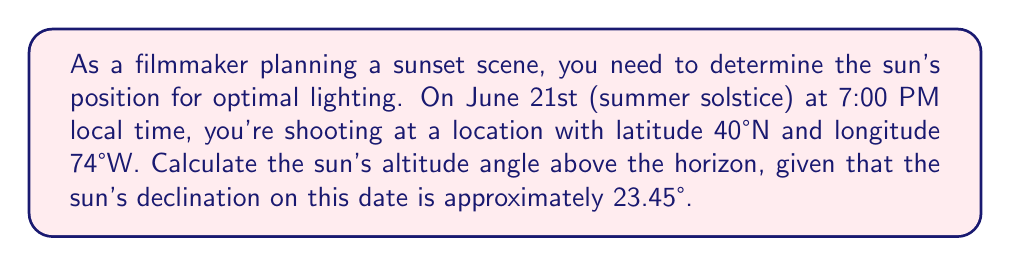Could you help me with this problem? To solve this problem, we'll use the celestial sphere model and the equation for solar altitude:

1. The equation for solar altitude is:
   $$\sin(h) = \sin(\phi)\sin(\delta) + \cos(\phi)\cos(\delta)\cos(H)$$
   Where:
   $h$ = solar altitude
   $\phi$ = latitude
   $\delta$ = solar declination
   $H$ = hour angle

2. We're given:
   $\phi = 40°$ (latitude)
   $\delta = 23.45°$ (declination on summer solstice)

3. Calculate the hour angle (H):
   - Local solar noon occurs when the sun is highest in the sky.
   - 7:00 PM is 7 hours after noon, so H = 15° × 7 = 105°
   
4. Substitute values into the equation:
   $$\sin(h) = \sin(40°)\sin(23.45°) + \cos(40°)\cos(23.45°)\cos(105°)$$

5. Calculate step by step:
   $$\sin(h) = (0.6428)(0.3978) + (0.7660)(0.9170)(-0.2588)$$
   $$\sin(h) = 0.2557 - 0.1820$$
   $$\sin(h) = 0.0737$$

6. Take the inverse sine (arcsin) of both sides:
   $$h = \arcsin(0.0737)$$
   $$h \approx 4.23°$$

This means the sun will be approximately 4.23° above the horizon at the specified time and location.
Answer: The sun's altitude angle above the horizon will be approximately 4.23°. 